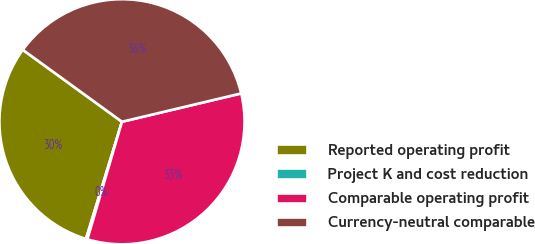<chart> <loc_0><loc_0><loc_500><loc_500><pie_chart><fcel>Reported operating profit<fcel>Project K and cost reduction<fcel>Comparable operating profit<fcel>Currency-neutral comparable<nl><fcel>30.24%<fcel>0.19%<fcel>33.27%<fcel>36.29%<nl></chart> 